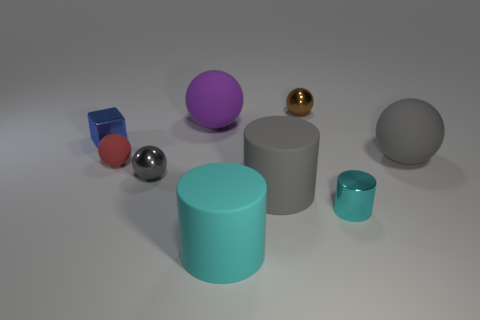Subtract all brown spheres. How many spheres are left? 4 Subtract 3 balls. How many balls are left? 2 Subtract all brown shiny spheres. How many spheres are left? 4 Subtract all purple balls. Subtract all purple cylinders. How many balls are left? 4 Add 1 tiny yellow balls. How many objects exist? 10 Subtract all cylinders. How many objects are left? 6 Add 3 big purple spheres. How many big purple spheres exist? 4 Subtract 0 green cylinders. How many objects are left? 9 Subtract all large brown balls. Subtract all small balls. How many objects are left? 6 Add 3 red spheres. How many red spheres are left? 4 